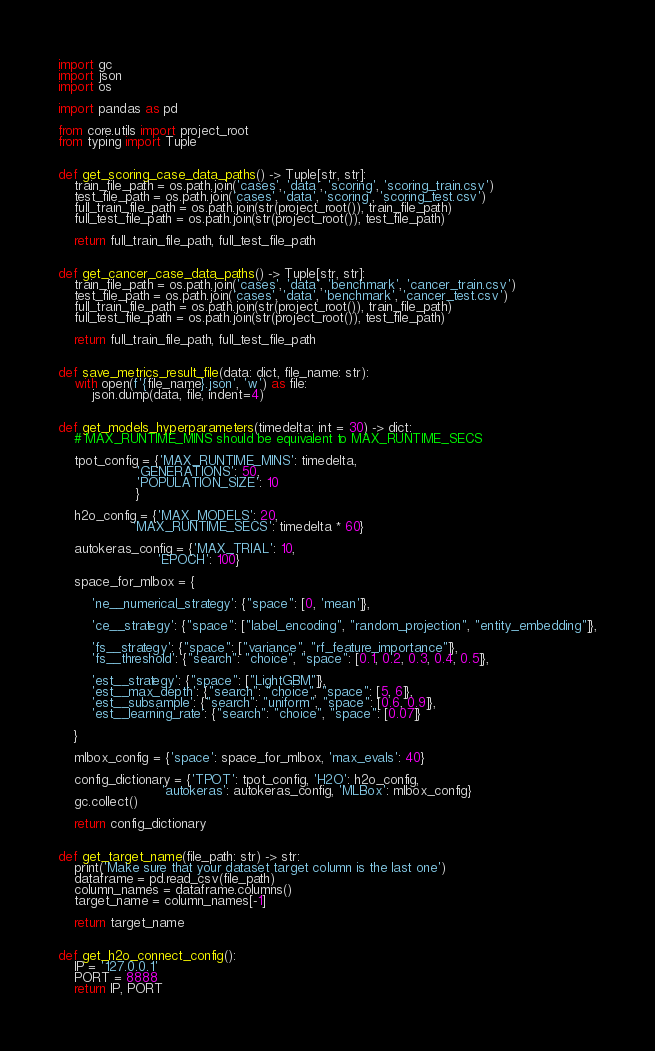Convert code to text. <code><loc_0><loc_0><loc_500><loc_500><_Python_>import gc
import json
import os

import pandas as pd

from core.utils import project_root
from typing import Tuple


def get_scoring_case_data_paths() -> Tuple[str, str]:
    train_file_path = os.path.join('cases', 'data', 'scoring', 'scoring_train.csv')
    test_file_path = os.path.join('cases', 'data', 'scoring', 'scoring_test.csv')
    full_train_file_path = os.path.join(str(project_root()), train_file_path)
    full_test_file_path = os.path.join(str(project_root()), test_file_path)

    return full_train_file_path, full_test_file_path


def get_cancer_case_data_paths() -> Tuple[str, str]:
    train_file_path = os.path.join('cases', 'data', 'benchmark', 'cancer_train.csv')
    test_file_path = os.path.join('cases', 'data', 'benchmark', 'cancer_test.csv')
    full_train_file_path = os.path.join(str(project_root()), train_file_path)
    full_test_file_path = os.path.join(str(project_root()), test_file_path)

    return full_train_file_path, full_test_file_path


def save_metrics_result_file(data: dict, file_name: str):
    with open(f'{file_name}.json', 'w') as file:
        json.dump(data, file, indent=4)


def get_models_hyperparameters(timedelta: int = 30) -> dict:
    # MAX_RUNTIME_MINS should be equivalent to MAX_RUNTIME_SECS

    tpot_config = {'MAX_RUNTIME_MINS': timedelta,
                   'GENERATIONS': 50,
                   'POPULATION_SIZE': 10
                   }

    h2o_config = {'MAX_MODELS': 20,
                  'MAX_RUNTIME_SECS': timedelta * 60}

    autokeras_config = {'MAX_TRIAL': 10,
                        'EPOCH': 100}

    space_for_mlbox = {

        'ne__numerical_strategy': {"space": [0, 'mean']},

        'ce__strategy': {"space": ["label_encoding", "random_projection", "entity_embedding"]},

        'fs__strategy': {"space": ["variance", "rf_feature_importance"]},
        'fs__threshold': {"search": "choice", "space": [0.1, 0.2, 0.3, 0.4, 0.5]},

        'est__strategy': {"space": ["LightGBM"]},
        'est__max_depth': {"search": "choice", "space": [5, 6]},
        'est__subsample': {"search": "uniform", "space": [0.6, 0.9]},
        'est__learning_rate': {"search": "choice", "space": [0.07]}

    }

    mlbox_config = {'space': space_for_mlbox, 'max_evals': 40}

    config_dictionary = {'TPOT': tpot_config, 'H2O': h2o_config,
                         'autokeras': autokeras_config, 'MLBox': mlbox_config}
    gc.collect()

    return config_dictionary


def get_target_name(file_path: str) -> str:
    print('Make sure that your dataset target column is the last one')
    dataframe = pd.read_csv(file_path)
    column_names = dataframe.columns()
    target_name = column_names[-1]

    return target_name


def get_h2o_connect_config():
    IP = '127.0.0.1'
    PORT = 8888
    return IP, PORT
</code> 